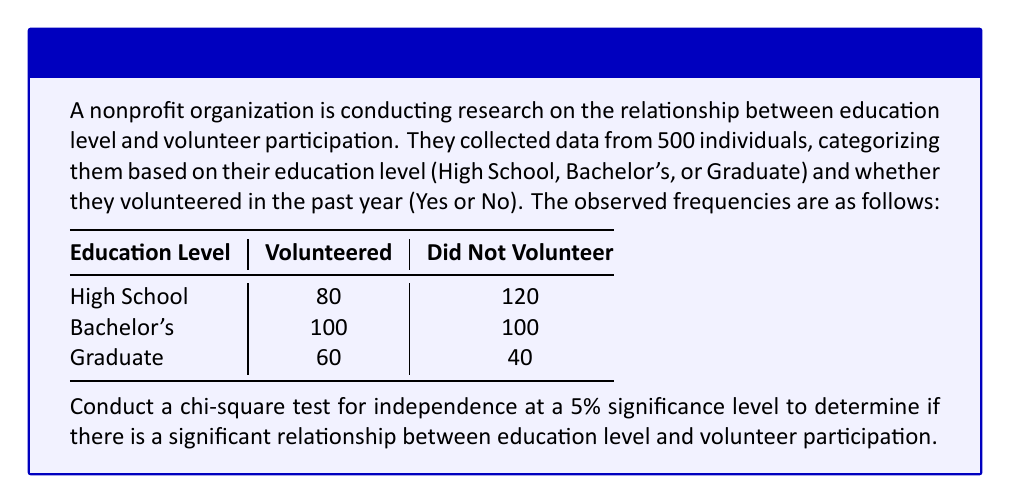What is the answer to this math problem? To conduct a chi-square test for independence, we'll follow these steps:

1. State the hypotheses:
   $H_0$: Education level and volunteer participation are independent
   $H_1$: Education level and volunteer participation are not independent

2. Calculate the expected frequencies:
   For each cell: $E = \frac{(\text{row total}) \times (\text{column total})}{\text{grand total}}$

   High School & Volunteered: $E = \frac{200 \times 240}{500} = 96$
   High School & Not Volunteered: $E = \frac{200 \times 260}{500} = 104$
   Bachelor's & Volunteered: $E = \frac{200 \times 240}{500} = 96$
   Bachelor's & Not Volunteered: $E = \frac{200 \times 260}{500} = 104$
   Graduate & Volunteered: $E = \frac{100 \times 240}{500} = 48$
   Graduate & Not Volunteered: $E = \frac{100 \times 260}{500} = 52$

3. Calculate the chi-square statistic:
   $$\chi^2 = \sum \frac{(O - E)^2}{E}$$

   $\chi^2 = \frac{(80-96)^2}{96} + \frac{(120-104)^2}{104} + \frac{(100-96)^2}{96} + \frac{(100-104)^2}{104} + \frac{(60-48)^2}{48} + \frac{(40-52)^2}{52}$

   $\chi^2 = 2.67 + 2.46 + 0.17 + 0.15 + 3.00 + 2.77 = 11.22$

4. Determine the degrees of freedom:
   $df = (r-1)(c-1) = (3-1)(2-1) = 2$

5. Find the critical value:
   At 5% significance level and 2 df, the critical value is 5.991

6. Compare the chi-square statistic to the critical value:
   $11.22 > 5.991$, so we reject the null hypothesis

7. Calculate the p-value:
   Using a chi-square distribution table or calculator, we find that the p-value is approximately 0.0037
Answer: Reject $H_0$ (p-value ≈ 0.0037). There is a significant relationship between education level and volunteer participation. 